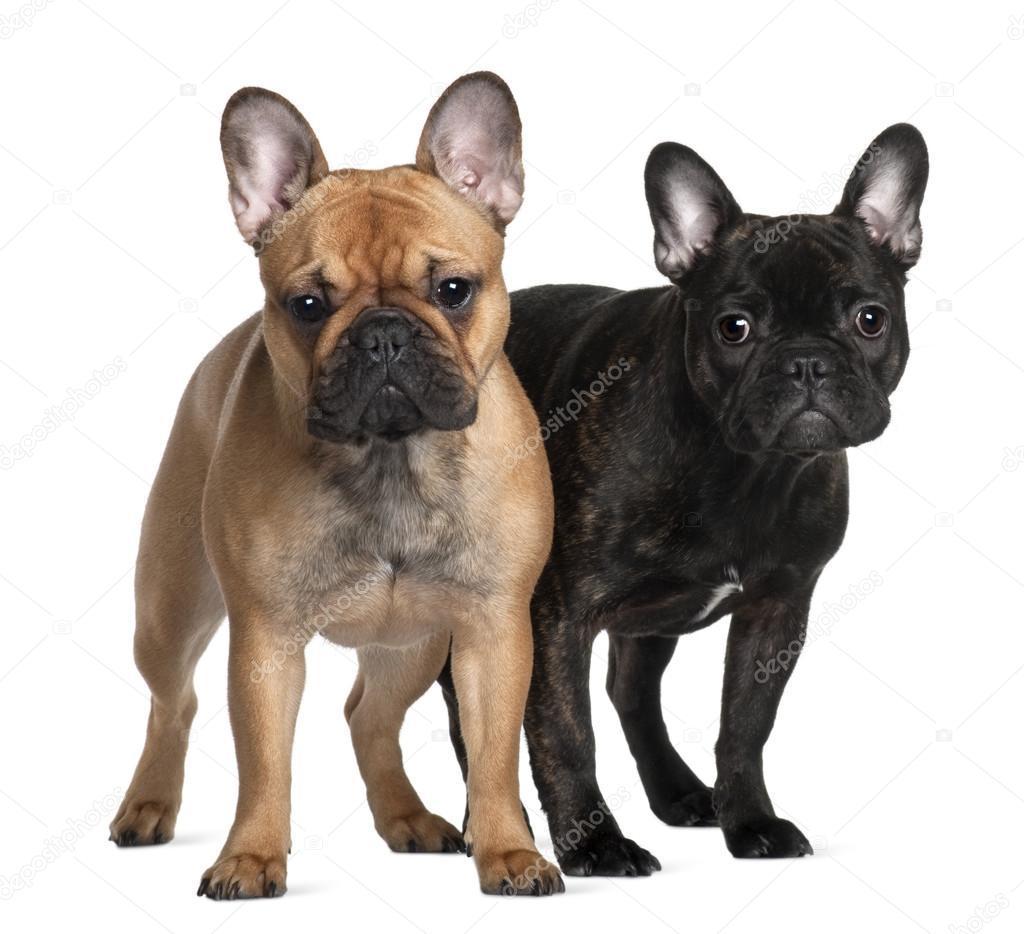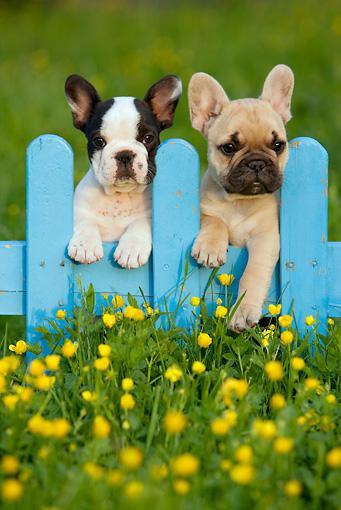The first image is the image on the left, the second image is the image on the right. For the images displayed, is the sentence "Each image contains a pair of big-eared dogs, and the pair on the left stand on all fours." factually correct? Answer yes or no. Yes. The first image is the image on the left, the second image is the image on the right. For the images shown, is this caption "Two dogs are standing up in the image on the left." true? Answer yes or no. Yes. 